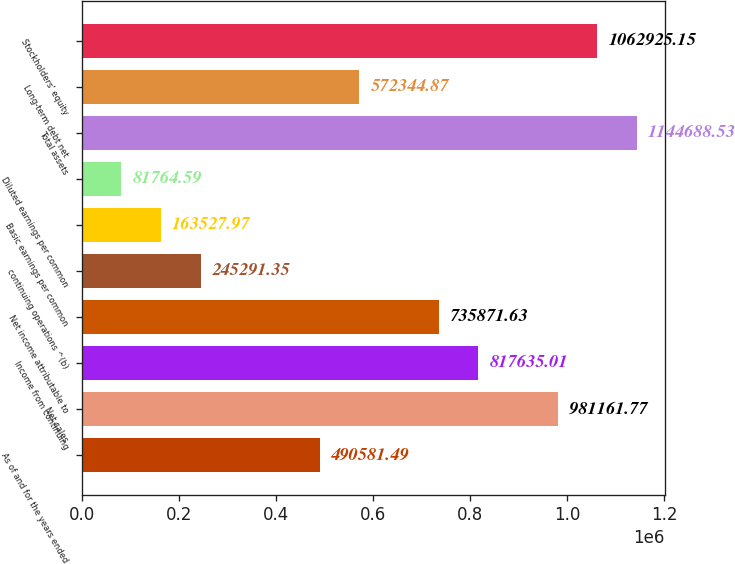Convert chart. <chart><loc_0><loc_0><loc_500><loc_500><bar_chart><fcel>As of and for the years ended<fcel>Net sales<fcel>Income from continuing<fcel>Net income attributable to<fcel>continuing operations ^(b)<fcel>Basic earnings per common<fcel>Diluted earnings per common<fcel>Total assets<fcel>Long-term debt net<fcel>Stockholders' equity<nl><fcel>490581<fcel>981162<fcel>817635<fcel>735872<fcel>245291<fcel>163528<fcel>81764.6<fcel>1.14469e+06<fcel>572345<fcel>1.06293e+06<nl></chart> 